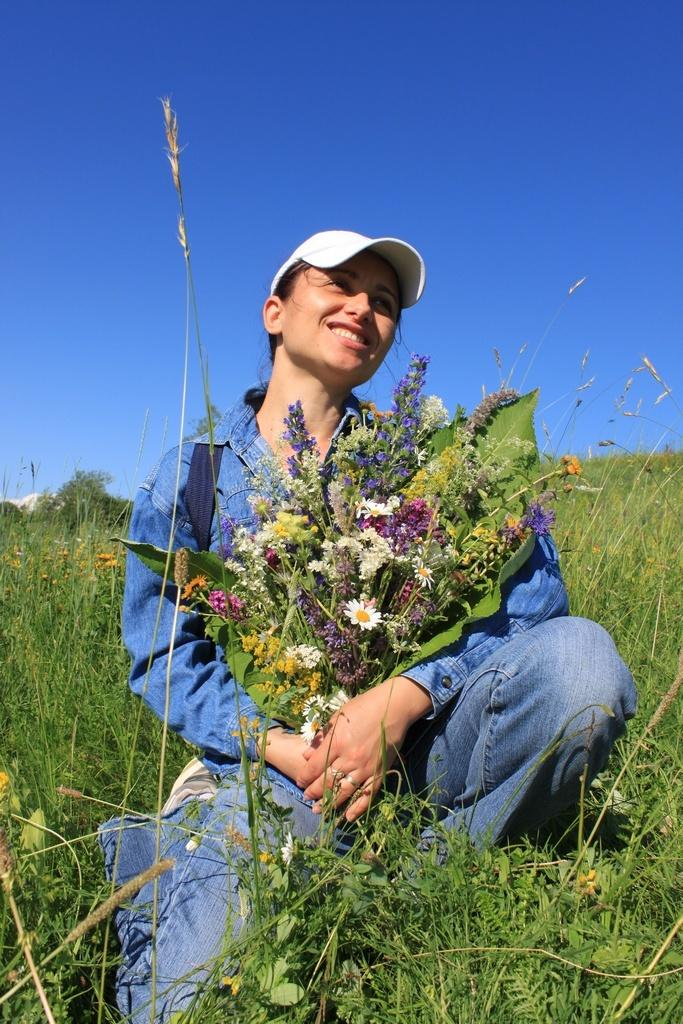Who is the main subject in the image? There is a woman in the center of the image. What is the woman doing in the image? The woman is sitting. What is the woman holding in the image? The woman is holding flowers. What type of vegetation can be seen at the bottom of the image? There are plants at the bottom of the image. What is visible at the top of the image? The sky is visible at the top of the image. What type of trade is the woman participating in with the cherry in the image? There is no cherry present in the image, and the woman is not participating in any trade. Is there a fireman visible in the image? No, there is no fireman present in the image. 